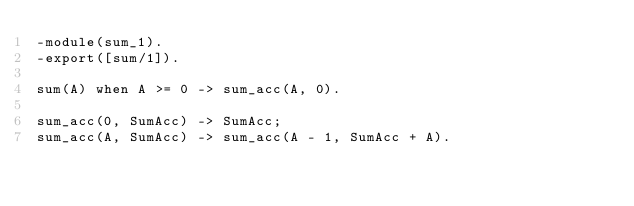<code> <loc_0><loc_0><loc_500><loc_500><_Erlang_>-module(sum_1).
-export([sum/1]).

sum(A) when A >= 0 -> sum_acc(A, 0).

sum_acc(0, SumAcc) -> SumAcc;
sum_acc(A, SumAcc) -> sum_acc(A - 1, SumAcc + A). </code> 